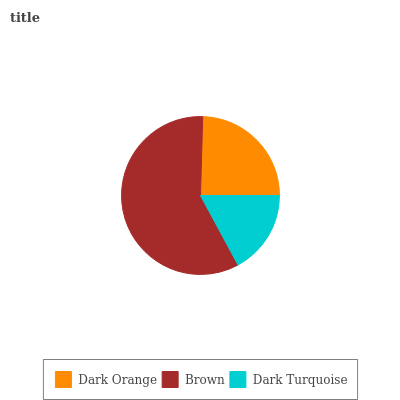Is Dark Turquoise the minimum?
Answer yes or no. Yes. Is Brown the maximum?
Answer yes or no. Yes. Is Brown the minimum?
Answer yes or no. No. Is Dark Turquoise the maximum?
Answer yes or no. No. Is Brown greater than Dark Turquoise?
Answer yes or no. Yes. Is Dark Turquoise less than Brown?
Answer yes or no. Yes. Is Dark Turquoise greater than Brown?
Answer yes or no. No. Is Brown less than Dark Turquoise?
Answer yes or no. No. Is Dark Orange the high median?
Answer yes or no. Yes. Is Dark Orange the low median?
Answer yes or no. Yes. Is Brown the high median?
Answer yes or no. No. Is Brown the low median?
Answer yes or no. No. 